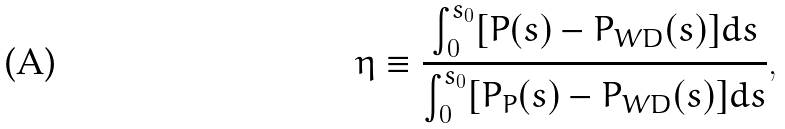Convert formula to latex. <formula><loc_0><loc_0><loc_500><loc_500>\eta \equiv \frac { \int _ { 0 } ^ { s _ { 0 } } [ P ( s ) - P _ { W D } ( s ) ] d s } { \int _ { 0 } ^ { s _ { 0 } } [ P _ { P } ( s ) - P _ { W D } ( s ) ] d s } ,</formula> 